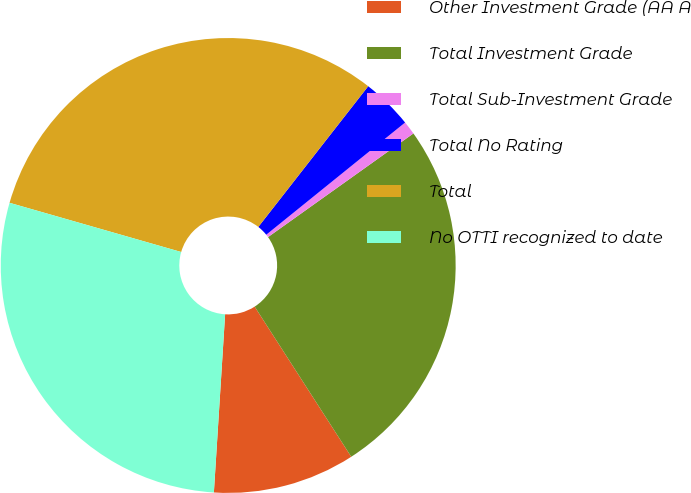Convert chart. <chart><loc_0><loc_0><loc_500><loc_500><pie_chart><fcel>Other Investment Grade (AA A<fcel>Total Investment Grade<fcel>Total Sub-Investment Grade<fcel>Total No Rating<fcel>Total<fcel>No OTTI recognized to date<nl><fcel>10.1%<fcel>25.76%<fcel>0.96%<fcel>3.63%<fcel>31.11%<fcel>28.44%<nl></chart> 